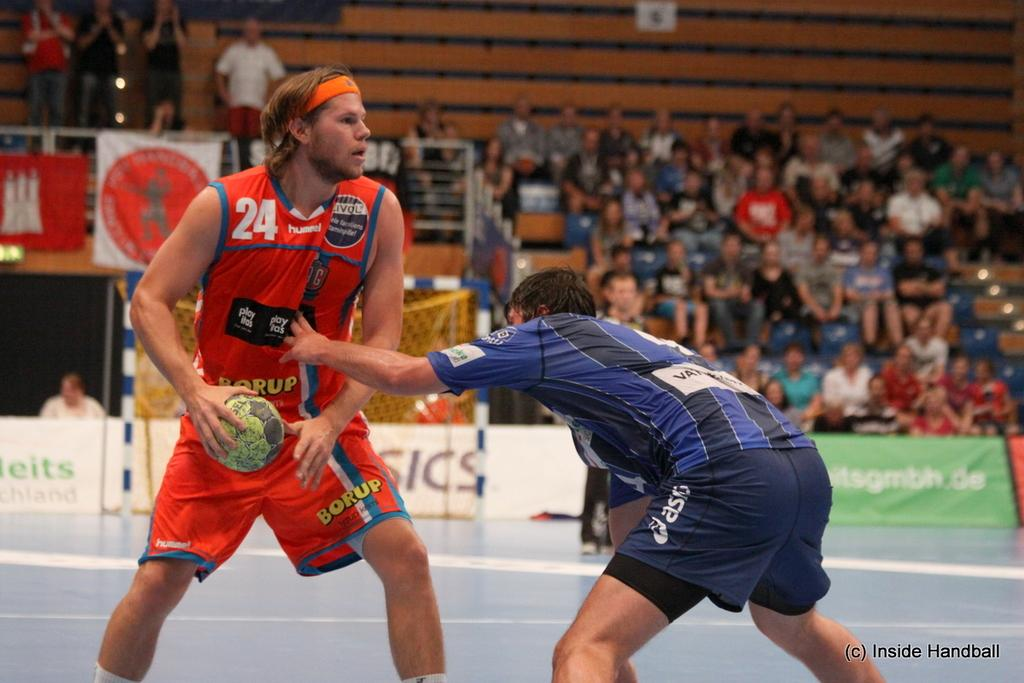Provide a one-sentence caption for the provided image. Player number 24 has the ball and looks for his teammates. 